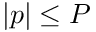Convert formula to latex. <formula><loc_0><loc_0><loc_500><loc_500>| p | \leq P</formula> 